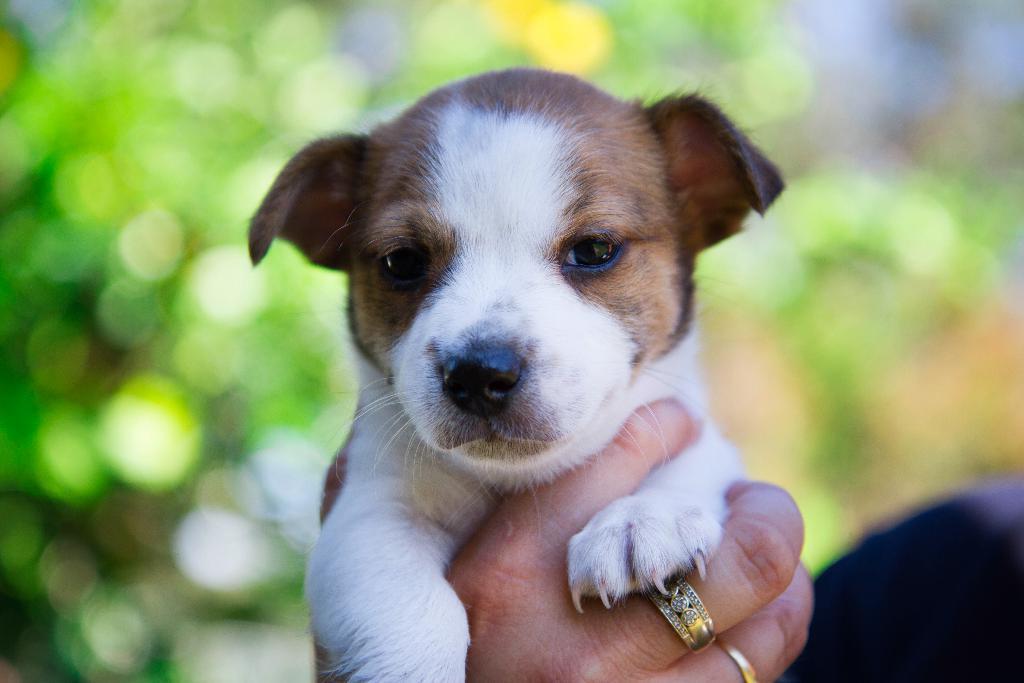In one or two sentences, can you explain what this image depicts? In this image we can see a person's hand holding a dog. Here we can see rings to the fingers. The background of the image is blurred. 